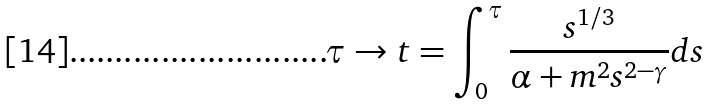Convert formula to latex. <formula><loc_0><loc_0><loc_500><loc_500>\tau \rightarrow t = \int _ { 0 } ^ { \tau } \frac { s ^ { 1 / 3 } } { \alpha + m ^ { 2 } s ^ { 2 - \gamma } } d s</formula> 